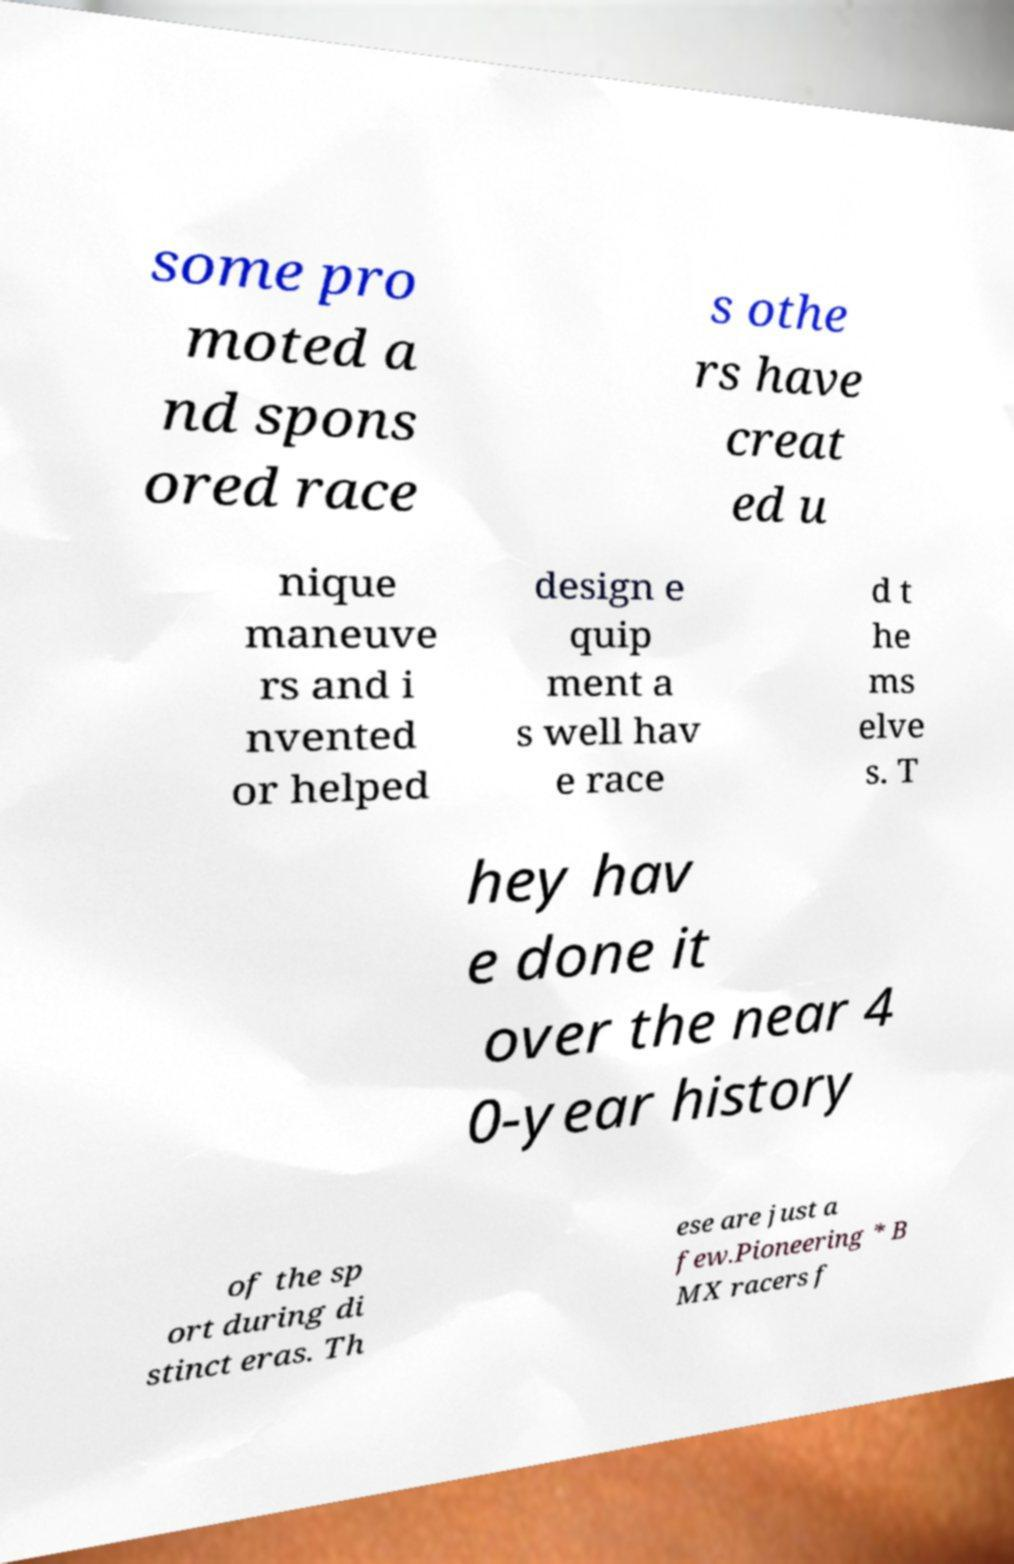There's text embedded in this image that I need extracted. Can you transcribe it verbatim? some pro moted a nd spons ored race s othe rs have creat ed u nique maneuve rs and i nvented or helped design e quip ment a s well hav e race d t he ms elve s. T hey hav e done it over the near 4 0-year history of the sp ort during di stinct eras. Th ese are just a few.Pioneering * B MX racers f 